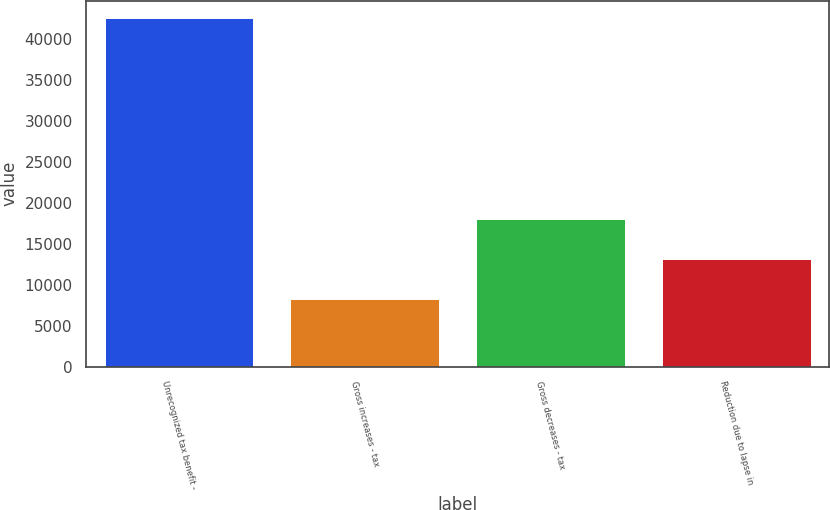Convert chart to OTSL. <chart><loc_0><loc_0><loc_500><loc_500><bar_chart><fcel>Unrecognized tax benefit -<fcel>Gross increases - tax<fcel>Gross decreases - tax<fcel>Reduction due to lapse in<nl><fcel>42594<fcel>8305.5<fcel>18094.5<fcel>13200<nl></chart> 